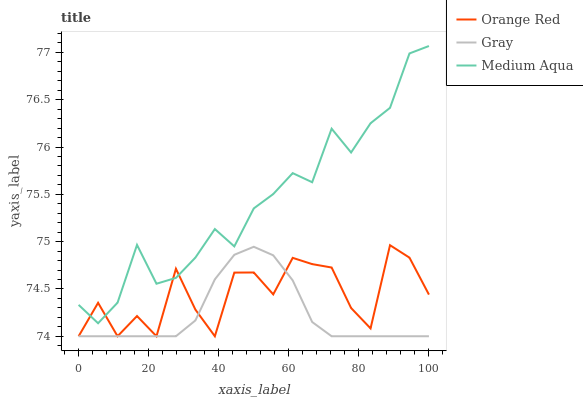Does Gray have the minimum area under the curve?
Answer yes or no. Yes. Does Medium Aqua have the maximum area under the curve?
Answer yes or no. Yes. Does Orange Red have the minimum area under the curve?
Answer yes or no. No. Does Orange Red have the maximum area under the curve?
Answer yes or no. No. Is Gray the smoothest?
Answer yes or no. Yes. Is Orange Red the roughest?
Answer yes or no. Yes. Is Medium Aqua the smoothest?
Answer yes or no. No. Is Medium Aqua the roughest?
Answer yes or no. No. Does Medium Aqua have the lowest value?
Answer yes or no. No. Does Medium Aqua have the highest value?
Answer yes or no. Yes. Does Orange Red have the highest value?
Answer yes or no. No. Is Gray less than Medium Aqua?
Answer yes or no. Yes. Is Medium Aqua greater than Gray?
Answer yes or no. Yes. Does Gray intersect Orange Red?
Answer yes or no. Yes. Is Gray less than Orange Red?
Answer yes or no. No. Is Gray greater than Orange Red?
Answer yes or no. No. Does Gray intersect Medium Aqua?
Answer yes or no. No. 